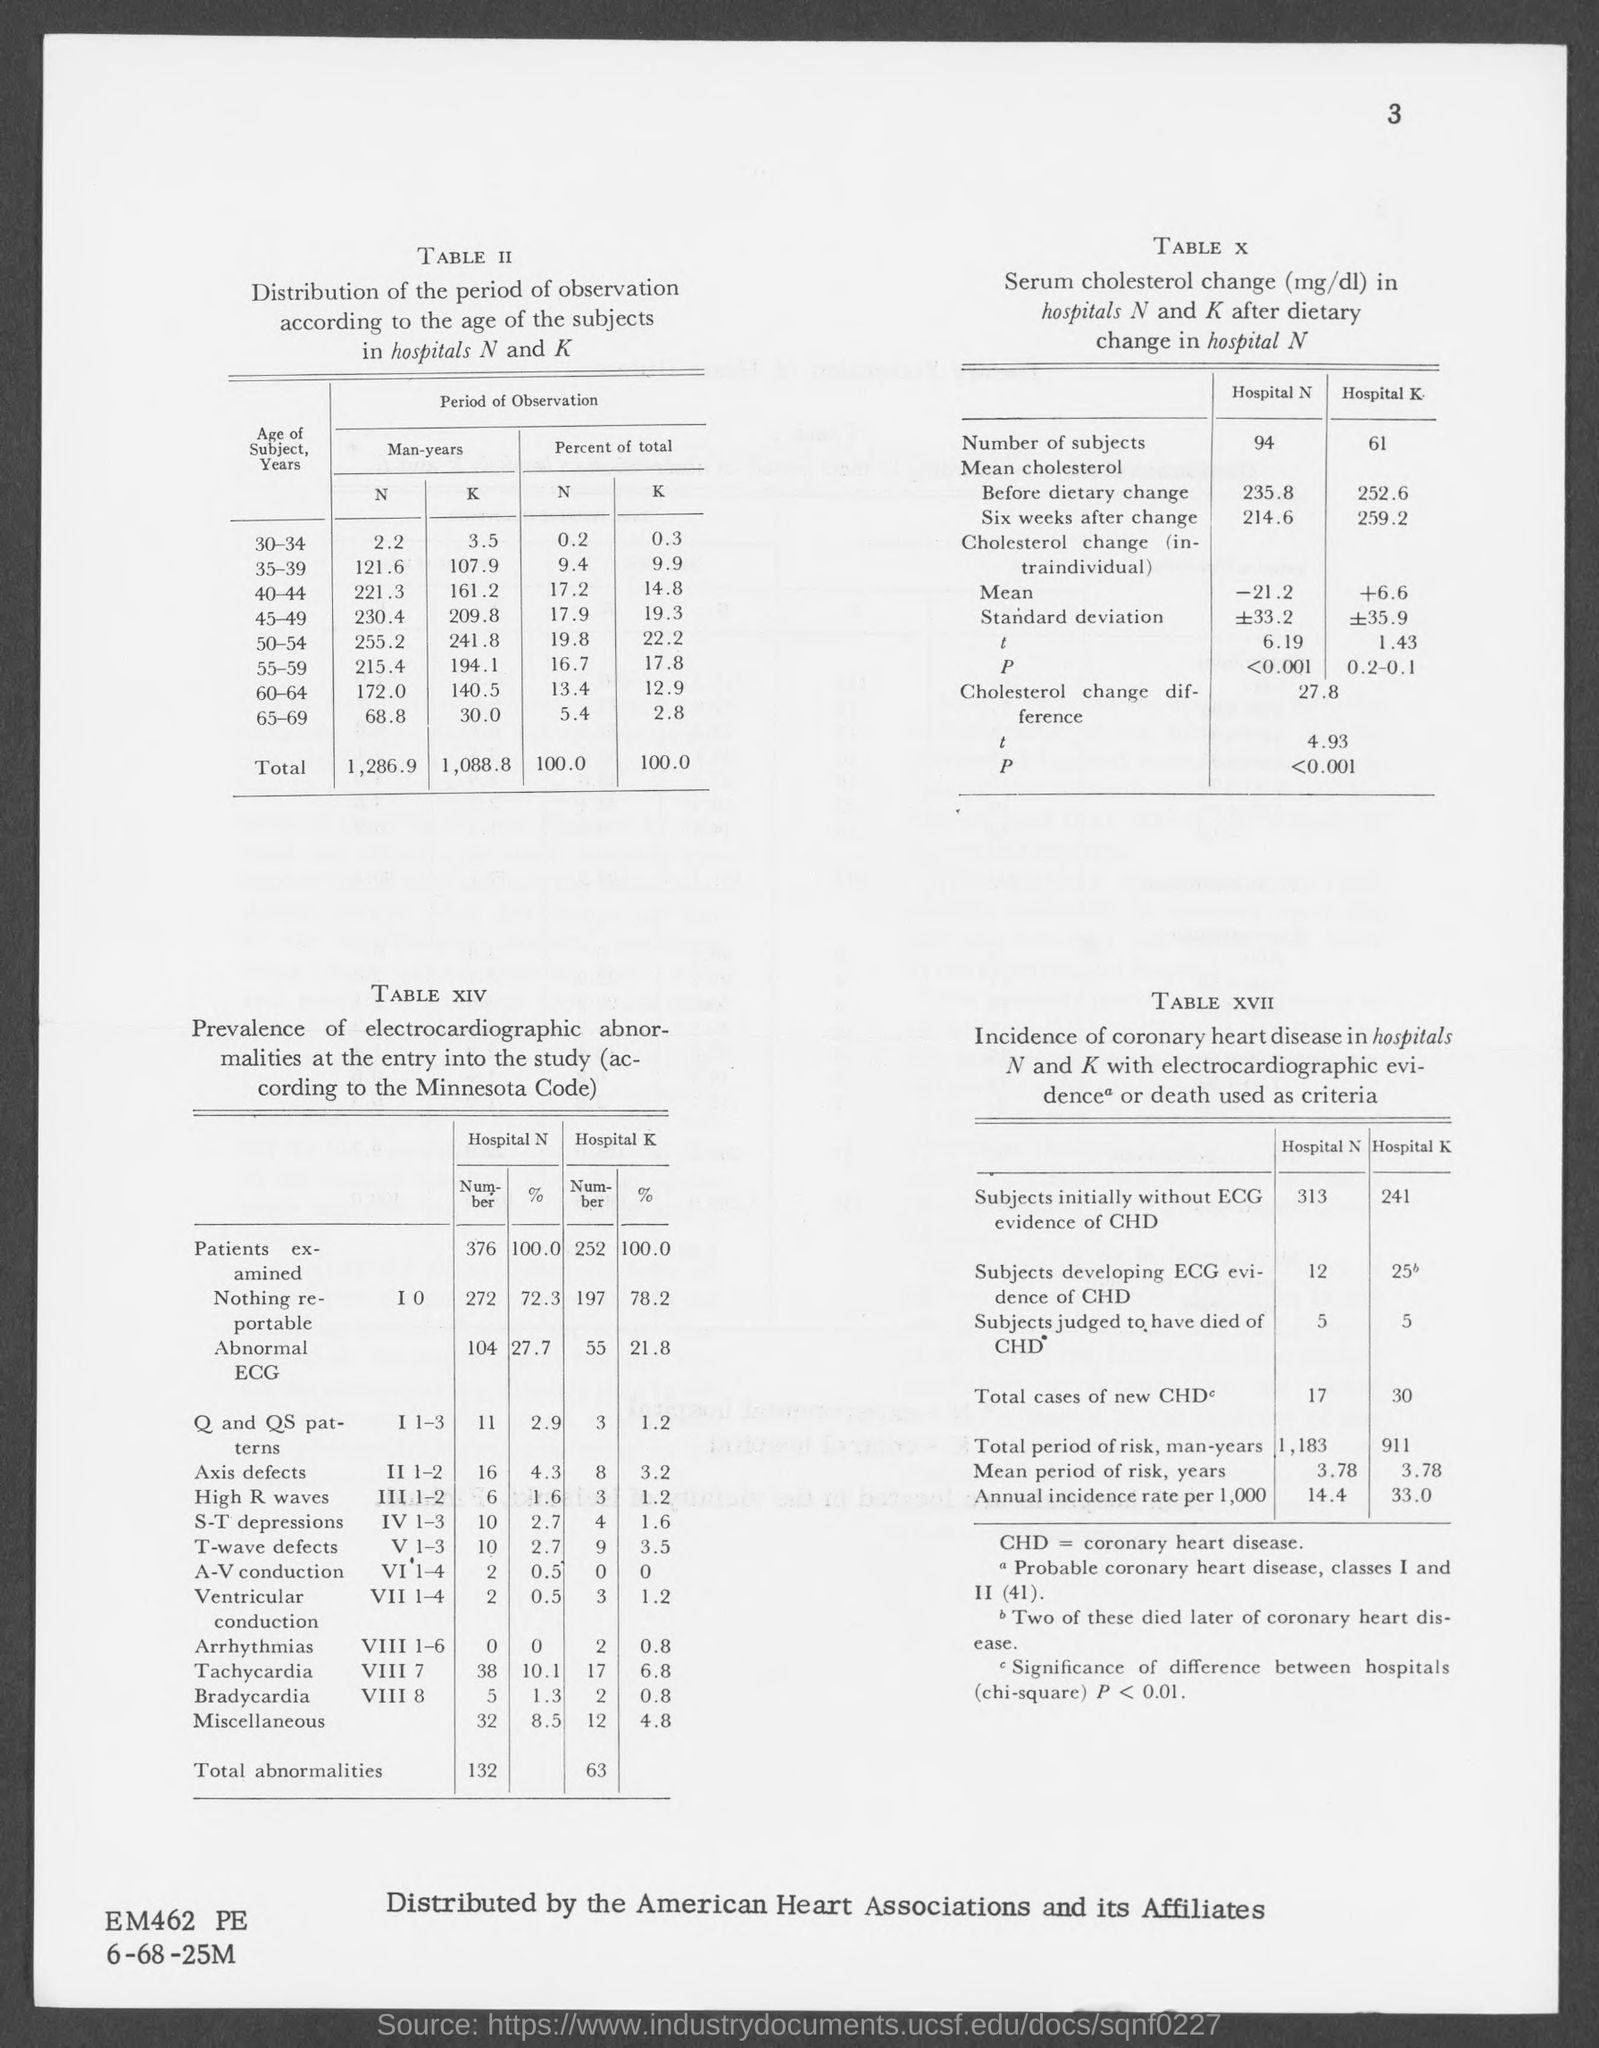Highlight a few significant elements in this photo. In table X, the number of subjects in Hospital K is 61. The total period of observation (in man-years) in hospital K is 1,088.8... Coronary Heart Disease" is an acronym that is commonly referred to as CHD. Table II shows the total period of observation in hospital N, which is 1,286.9 man-years. In table XVII, the total number of new cases of CHD in Hospital N is 17. 